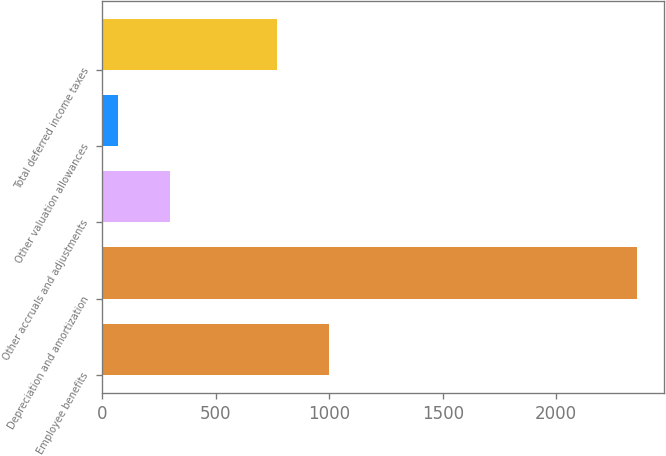Convert chart. <chart><loc_0><loc_0><loc_500><loc_500><bar_chart><fcel>Employee benefits<fcel>Depreciation and amortization<fcel>Other accruals and adjustments<fcel>Other valuation allowances<fcel>Total deferred income taxes<nl><fcel>998.5<fcel>2356<fcel>299.5<fcel>71<fcel>770<nl></chart> 